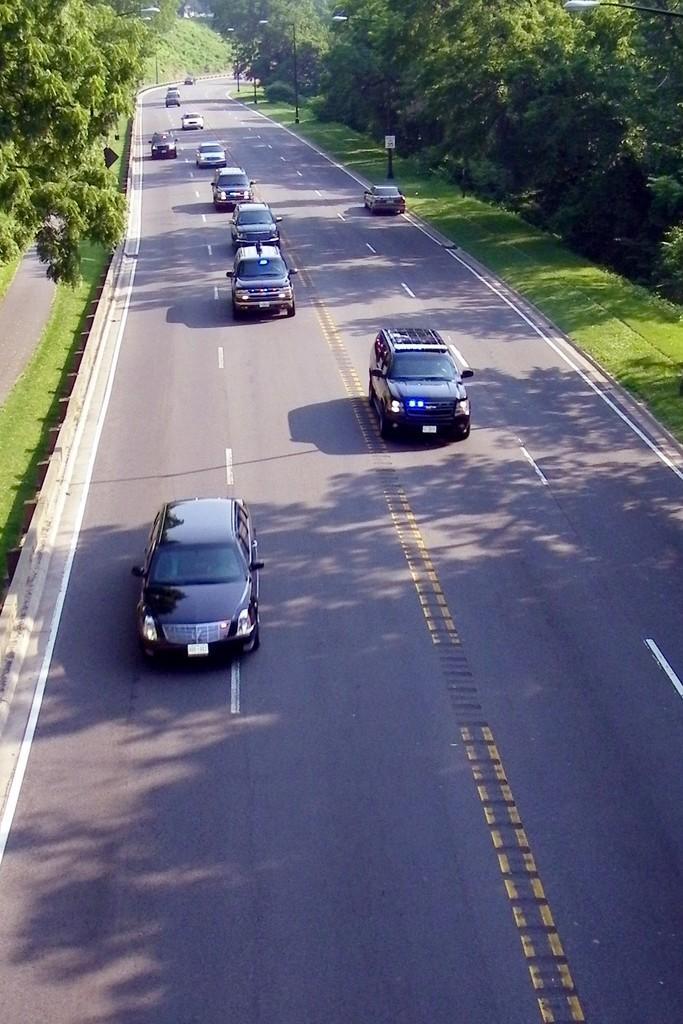How would you summarize this image in a sentence or two? In this image at the bottom there is a road on the road there are some cars, and on the right side and left side there are some trees, grass and some poles. 